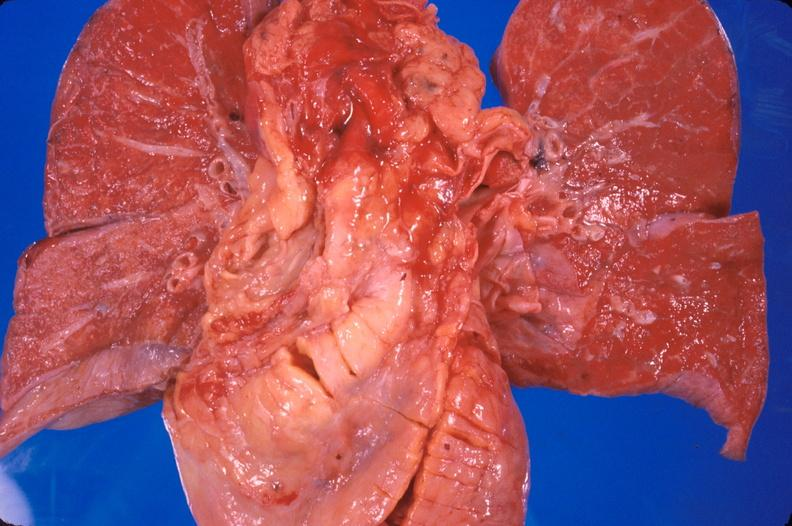what is present?
Answer the question using a single word or phrase. Cardiovascular 